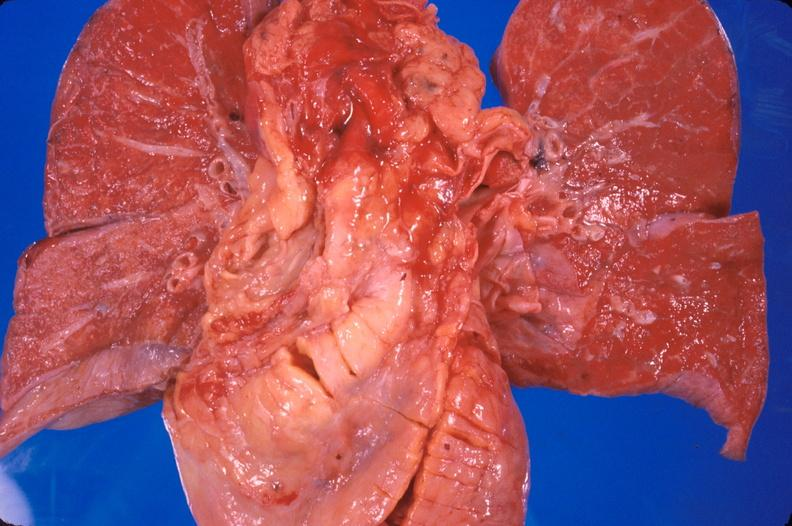what is present?
Answer the question using a single word or phrase. Cardiovascular 